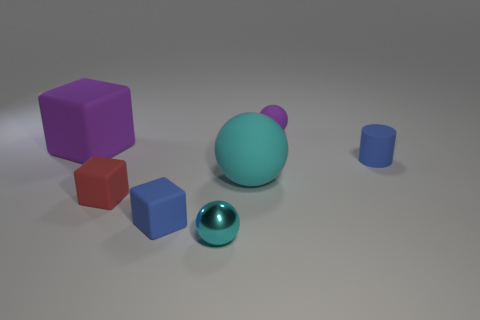Subtract all cyan spheres. How many spheres are left? 1 Subtract all cyan spheres. How many spheres are left? 1 Add 2 matte balls. How many objects exist? 9 Subtract all cylinders. How many objects are left? 6 Subtract 1 cubes. How many cubes are left? 2 Add 1 rubber spheres. How many rubber spheres exist? 3 Subtract 0 purple cylinders. How many objects are left? 7 Subtract all green cubes. Subtract all red cylinders. How many cubes are left? 3 Subtract all cyan cylinders. How many gray balls are left? 0 Subtract all large purple matte blocks. Subtract all purple things. How many objects are left? 4 